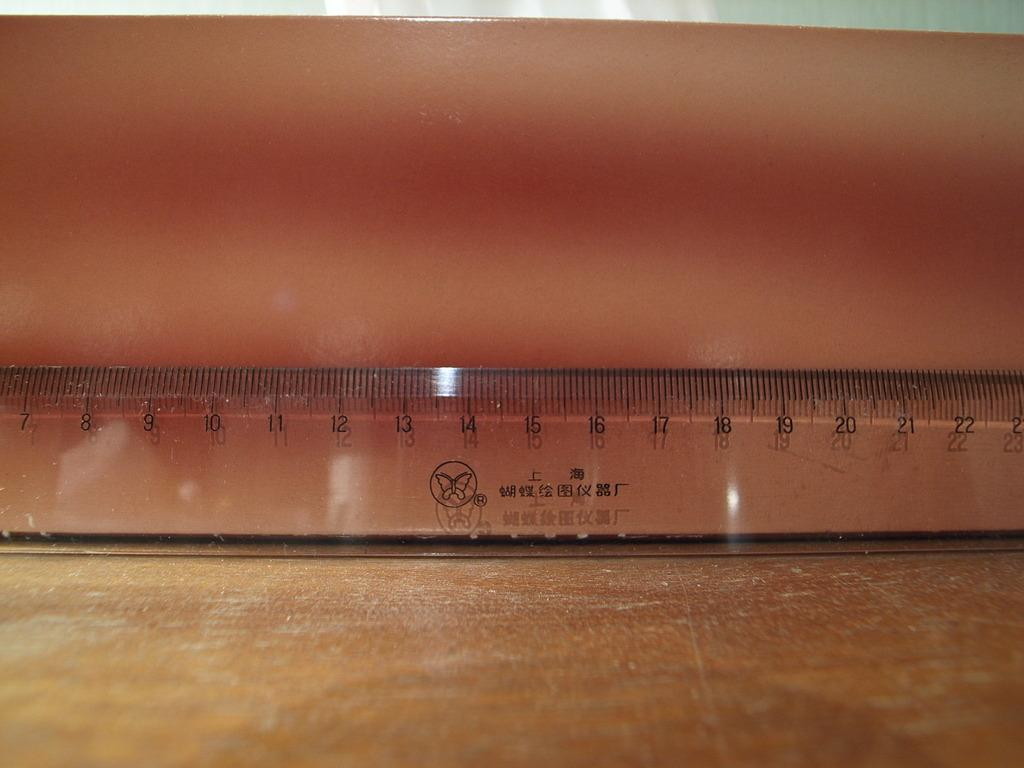Provide a one-sentence caption for the provided image. A see through Chinese ruler with centimeter marks between 7 and 22 are displayed. 